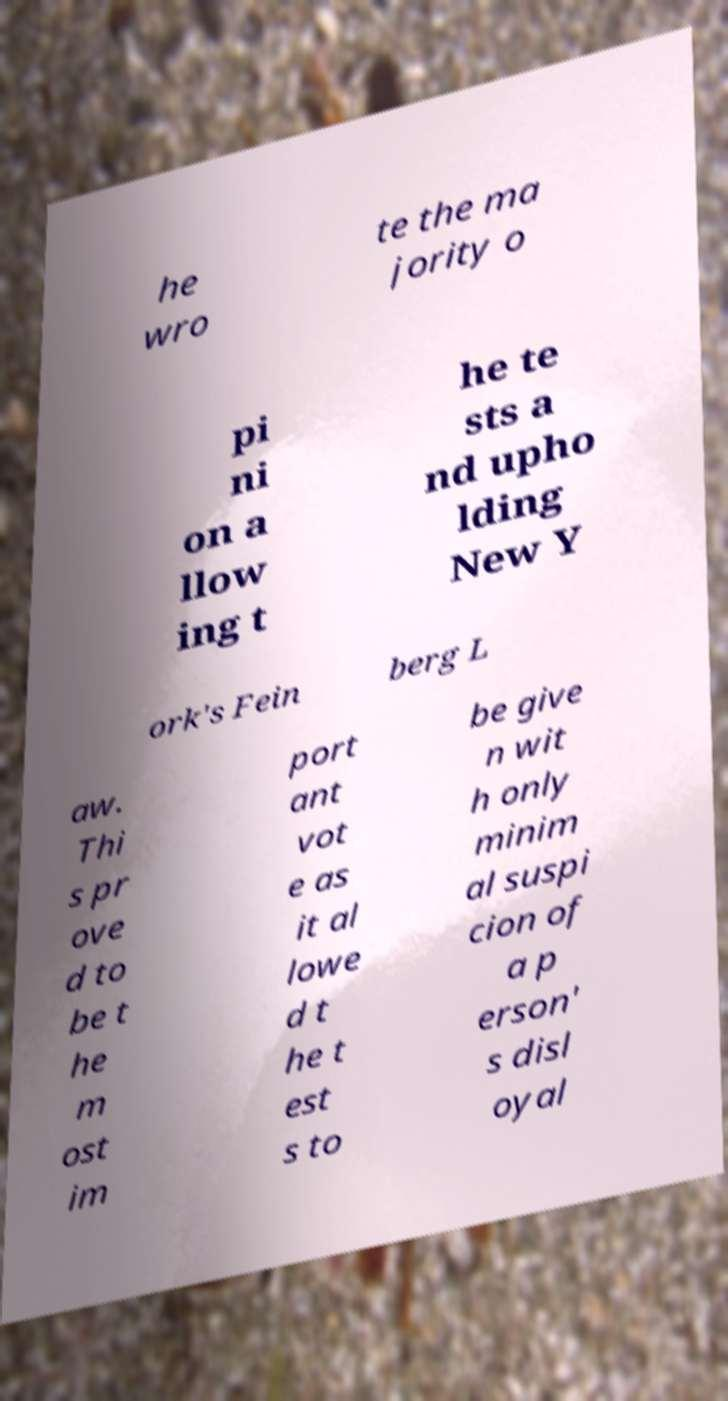Could you extract and type out the text from this image? he wro te the ma jority o pi ni on a llow ing t he te sts a nd upho lding New Y ork's Fein berg L aw. Thi s pr ove d to be t he m ost im port ant vot e as it al lowe d t he t est s to be give n wit h only minim al suspi cion of a p erson' s disl oyal 